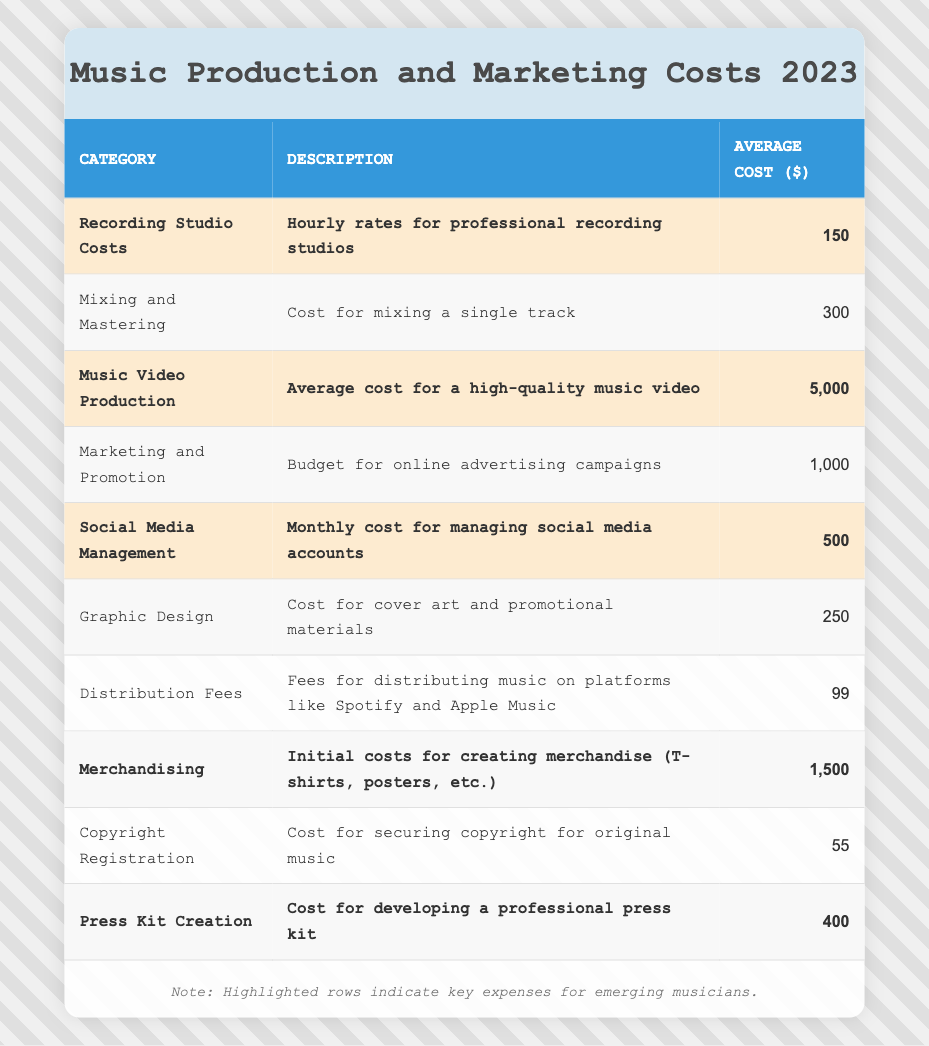What is the average cost of Recording Studio Costs? The table states that the average cost for Recording Studio Costs is listed as 150.
Answer: 150 What is the total of the highlighted costs? To find the total, add all highlighted costs: 150 (Recording Studio) + 5000 (Music Video Production) + 500 (Social Media Management) + 1500 (Merchandising) + 400 (Press Kit Creation) = 6550.
Answer: 6550 Is the cost for Copyright Registration above 50? The table specifies that the cost for Copyright Registration is 55, which is above 50.
Answer: Yes What is the difference between the cost of Music Video Production and Mixing and Mastering? The Music Video Production cost is 5000 and Mixing and Mastering cost is 300; the difference, therefore, is 5000 - 300 = 4700.
Answer: 4700 Which costs are higher, Mixing and Mastering or Social Media Management? Mixing and Mastering costs 300 and Social Media Management costs 500; since 500 is greater than 300, Social Media Management is higher.
Answer: Social Media Management What is the average cost of the highlighted expenses? The highlighted expenses total 6550 and there are 5 of them. So, average cost = 6550 / 5 = 1310.
Answer: 1310 How many expenses listed have a cost of less than 1000? The costs less than 1000 are: Recording Studio (150), Mixing and Mastering (300), Social Media Management (500), Graphic Design (250), Distribution Fees (99), and Copyright Registration (55). That's a total of 6 expenses.
Answer: 6 Is there any cost listed for Marketing and Promotion? The table includes a row for Marketing and Promotion, indicating that there is indeed a cost.
Answer: Yes What is the most expensive item on the list? The table indicates that the most expensive item is Music Video Production at 5000.
Answer: Music Video Production What is the cost of Press Kit Creation compared to Distribution Fees? The cost for Press Kit Creation is 400 and for Distribution Fees is 99; thus, Press Kit Creation is significantly higher.
Answer: Higher 